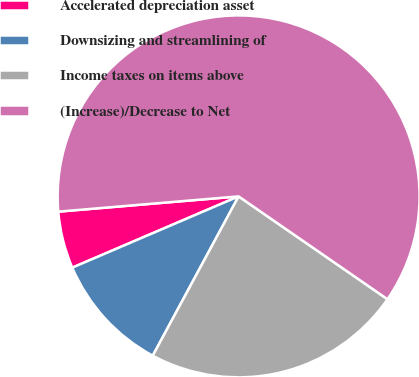Convert chart. <chart><loc_0><loc_0><loc_500><loc_500><pie_chart><fcel>Accelerated depreciation asset<fcel>Downsizing and streamlining of<fcel>Income taxes on items above<fcel>(Increase)/Decrease to Net<nl><fcel>5.1%<fcel>10.69%<fcel>23.25%<fcel>60.97%<nl></chart> 